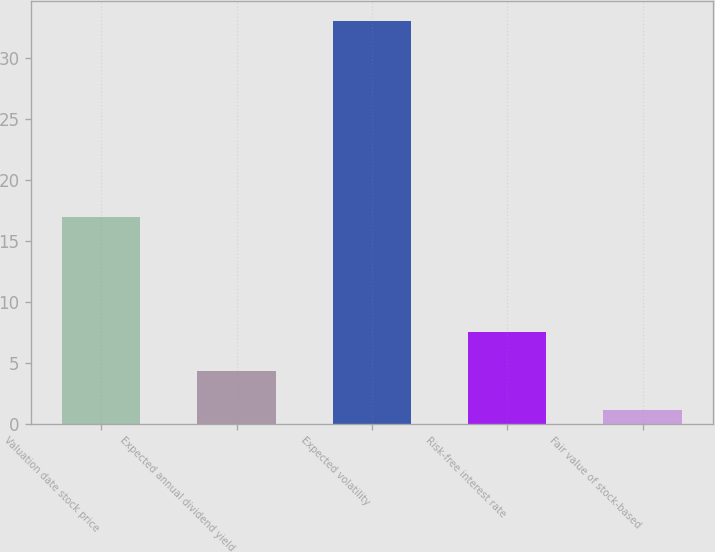Convert chart. <chart><loc_0><loc_0><loc_500><loc_500><bar_chart><fcel>Valuation date stock price<fcel>Expected annual dividend yield<fcel>Expected volatility<fcel>Risk-free interest rate<fcel>Fair value of stock-based<nl><fcel>16.93<fcel>4.28<fcel>33<fcel>7.47<fcel>1.09<nl></chart> 